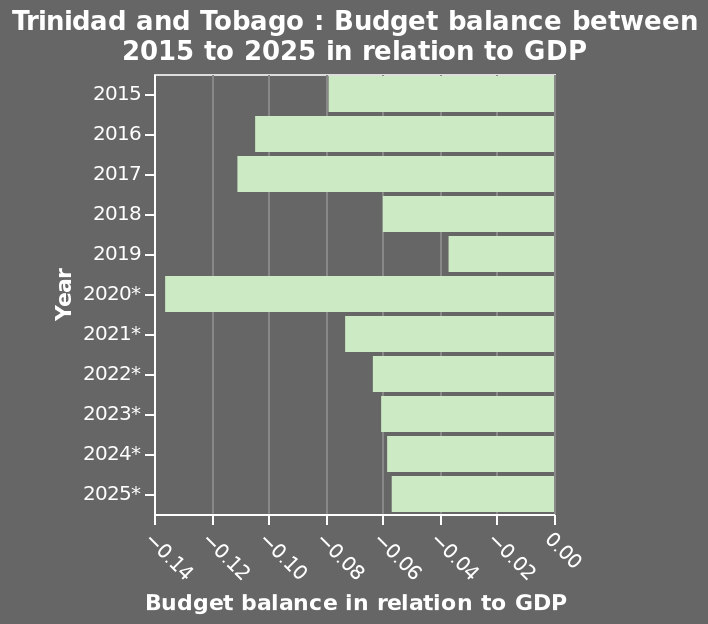<image>
Has the budget balance in Trinidad and Tobago improved or worsened from 2019 to 2020? The budget balance in Trinidad and Tobago worsened from 2019 to 2020. What does the bar diagram represent? The bar diagram represents the budget balance between 2015 to 2025 in relation to GDP for Trinidad and Tobago. What is the trend in the budget balance in Trinidad and Tobago based on the given information? The trend in the budget balance in Trinidad and Tobago shows a decrease from 2019 to 2020 and is expected to slightly improve by 2025. Describe the following image in detail Trinidad and Tobago : Budget balance between 2015 to 2025 in relation to GDP is a bar diagram. There is a categorical scale from −0.14 to 0.00 on the x-axis, marked Budget balance in relation to GDP. There is a categorical scale from 2015 to 2025* along the y-axis, labeled Year. What is the expected budget balance in Trinidad and Tobago in 2025?  The expected budget balance in Trinidad and Tobago in 2025 is approximately -0.06. Did the budget balance in Trinidad and Tobago increase or decrease in 2019?  The budget balance in Trinidad and Tobago fell in 2019. 